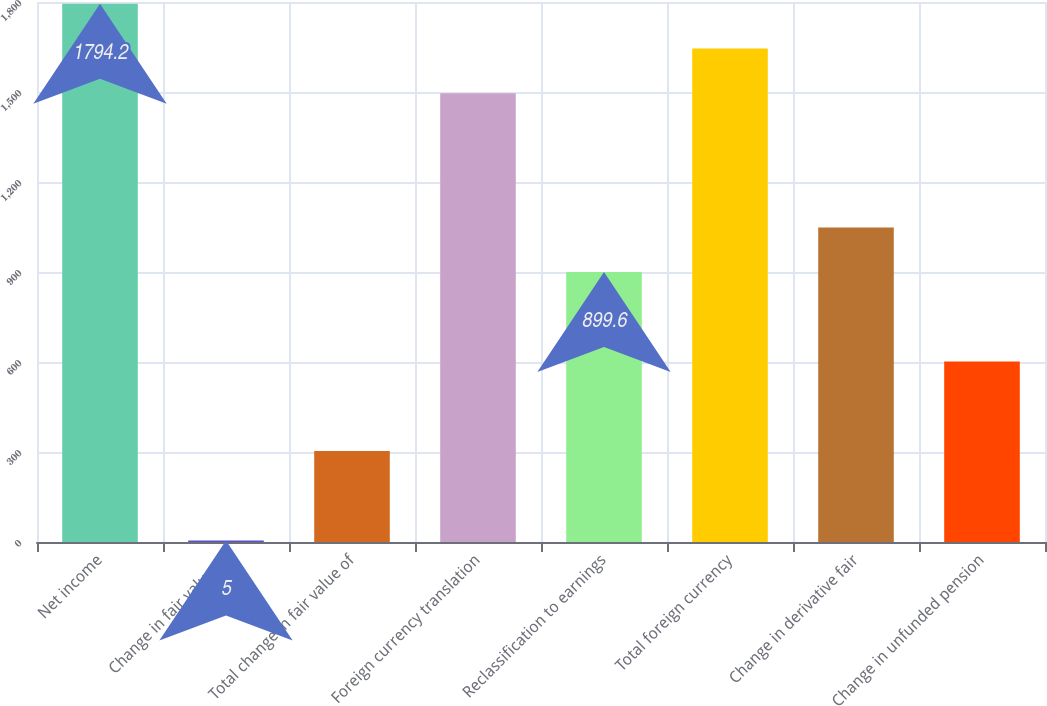Convert chart to OTSL. <chart><loc_0><loc_0><loc_500><loc_500><bar_chart><fcel>Net income<fcel>Change in fair value of<fcel>Total change in fair value of<fcel>Foreign currency translation<fcel>Reclassification to earnings<fcel>Total foreign currency<fcel>Change in derivative fair<fcel>Change in unfunded pension<nl><fcel>1794.2<fcel>5<fcel>303.2<fcel>1496<fcel>899.6<fcel>1645.1<fcel>1048.7<fcel>601.4<nl></chart> 